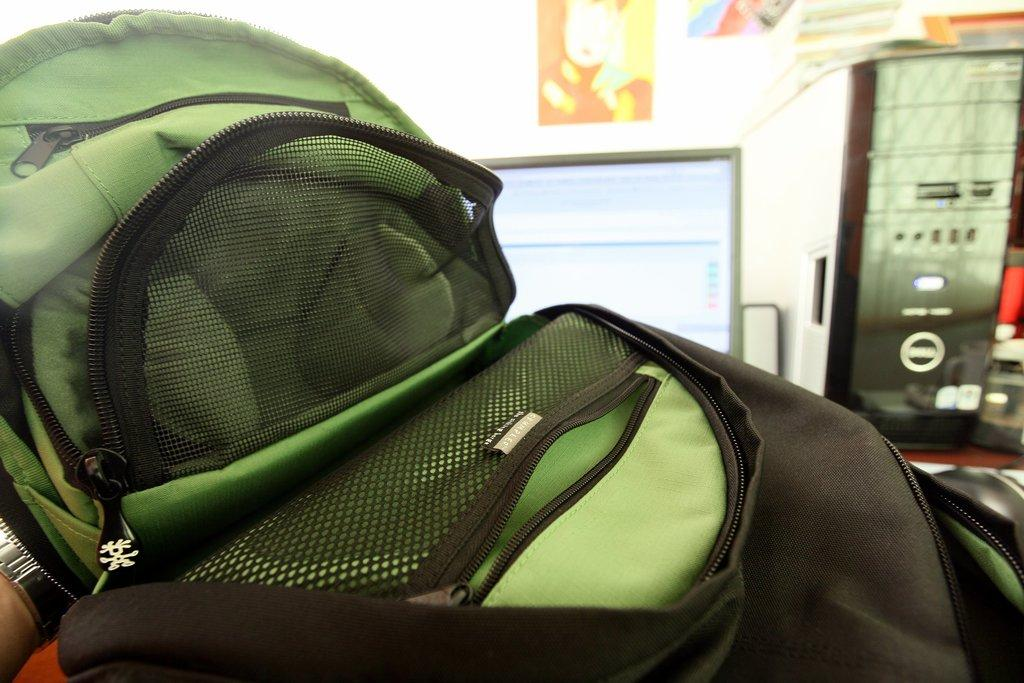What object is present in the image? The bag is in the image. What colors can be seen on the bag? The bag is green and black in color. What can be seen in the background of the image? There is a monitor and a wall in the background of the image. What is on the wall in the background? There are posters on the wall. Can you see a brush being used to clean the monitor in the image? There is no brush or cleaning activity visible in the image. 